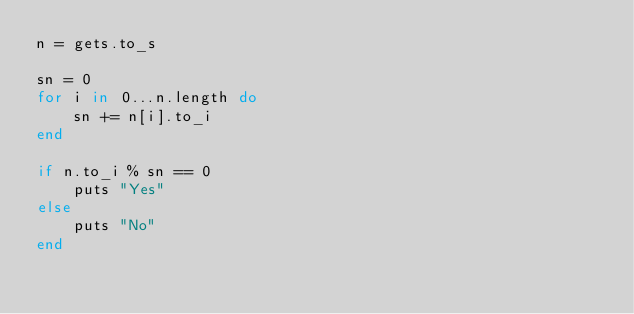Convert code to text. <code><loc_0><loc_0><loc_500><loc_500><_Ruby_>n = gets.to_s

sn = 0
for i in 0...n.length do
    sn += n[i].to_i
end

if n.to_i % sn == 0
    puts "Yes"
else
    puts "No"
end
</code> 